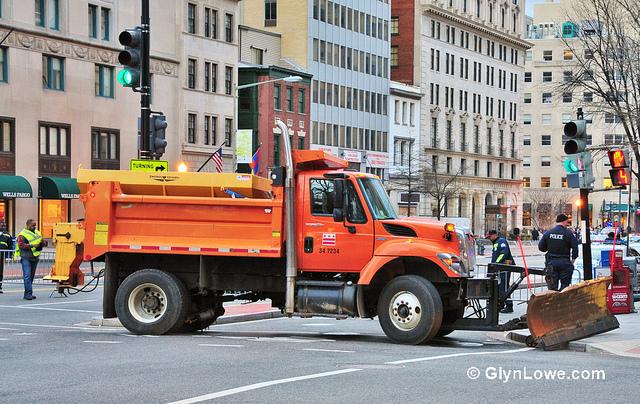Is there a plow attached to the truck?
Quick response, please. Yes. What does the traffic light signal indicate?
Answer briefly. Go. What color is the truck?
Short answer required. Orange. 